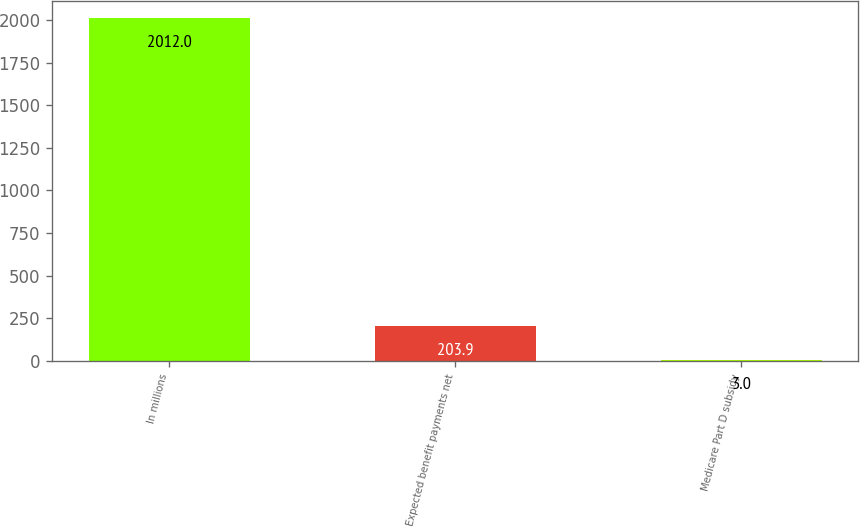<chart> <loc_0><loc_0><loc_500><loc_500><bar_chart><fcel>In millions<fcel>Expected benefit payments net<fcel>Medicare Part D subsidy<nl><fcel>2012<fcel>203.9<fcel>3<nl></chart> 